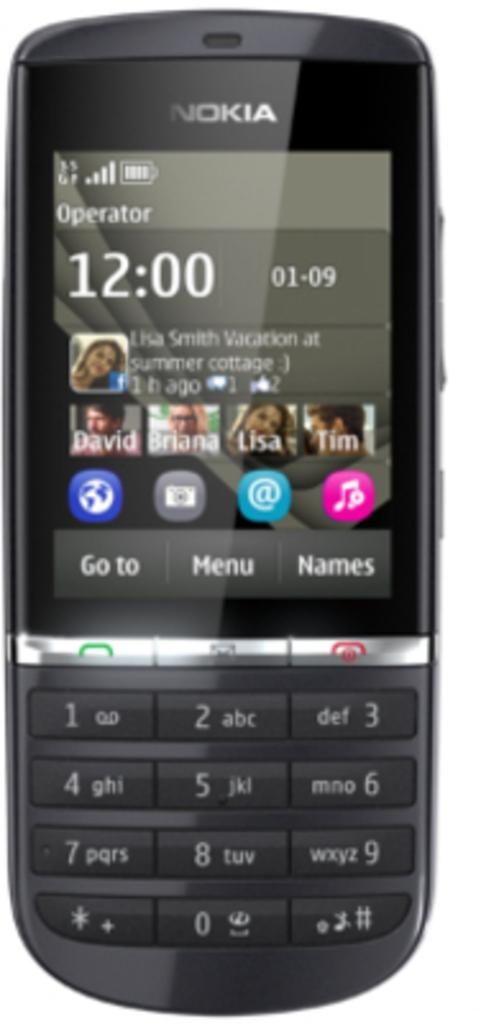What electronic device is visible in the image? There is a mobile phone in the image. Can you describe the appearance of the mobile phone? The mobile phone appears to be a standard smartphone with a touchscreen display. What might the person holding the mobile phone be doing? The person might be using the mobile phone to make a call, send a message, or access an app. What type of pickle is being served on the sofa in the image? There is no sofa or pickle present in the image; it only features a mobile phone. 